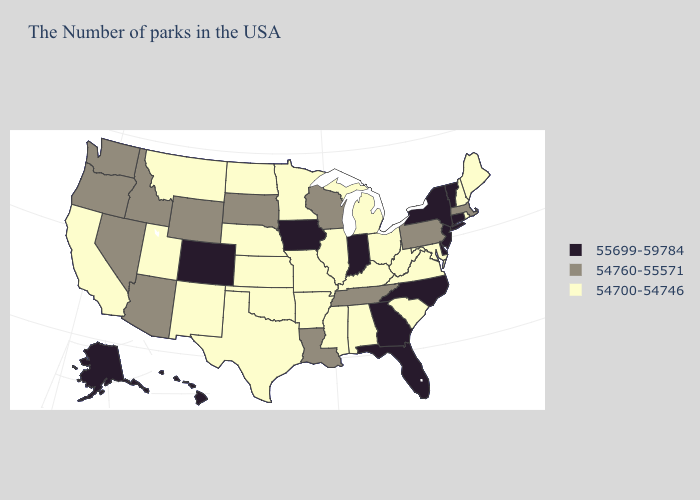Does Kansas have the highest value in the MidWest?
Answer briefly. No. Which states have the lowest value in the USA?
Keep it brief. Maine, Rhode Island, New Hampshire, Maryland, Virginia, South Carolina, West Virginia, Ohio, Michigan, Kentucky, Alabama, Illinois, Mississippi, Missouri, Arkansas, Minnesota, Kansas, Nebraska, Oklahoma, Texas, North Dakota, New Mexico, Utah, Montana, California. Does Connecticut have the highest value in the Northeast?
Concise answer only. Yes. What is the value of Mississippi?
Quick response, please. 54700-54746. Among the states that border Connecticut , which have the highest value?
Quick response, please. New York. Is the legend a continuous bar?
Answer briefly. No. What is the value of Montana?
Keep it brief. 54700-54746. Does Rhode Island have the highest value in the Northeast?
Concise answer only. No. What is the lowest value in the USA?
Give a very brief answer. 54700-54746. Does Kansas have the same value as Virginia?
Keep it brief. Yes. Which states hav the highest value in the South?
Give a very brief answer. Delaware, North Carolina, Florida, Georgia. Which states have the lowest value in the South?
Short answer required. Maryland, Virginia, South Carolina, West Virginia, Kentucky, Alabama, Mississippi, Arkansas, Oklahoma, Texas. What is the value of Kentucky?
Short answer required. 54700-54746. Among the states that border Vermont , which have the highest value?
Give a very brief answer. New York. Name the states that have a value in the range 54700-54746?
Write a very short answer. Maine, Rhode Island, New Hampshire, Maryland, Virginia, South Carolina, West Virginia, Ohio, Michigan, Kentucky, Alabama, Illinois, Mississippi, Missouri, Arkansas, Minnesota, Kansas, Nebraska, Oklahoma, Texas, North Dakota, New Mexico, Utah, Montana, California. 